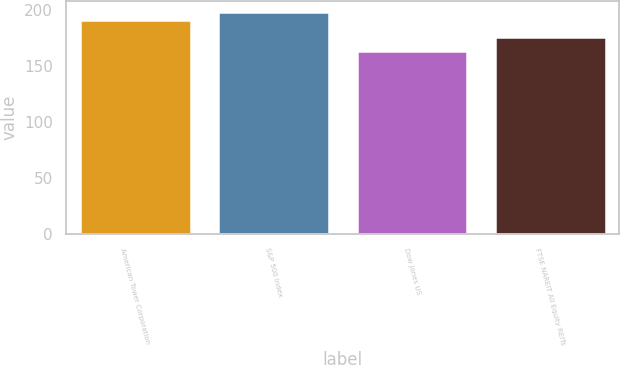Convert chart to OTSL. <chart><loc_0><loc_0><loc_500><loc_500><bar_chart><fcel>American Tower Corporation<fcel>S&P 500 Index<fcel>Dow Jones US<fcel>FTSE NAREIT All Equity REITs<nl><fcel>191.16<fcel>198.18<fcel>163.17<fcel>176.07<nl></chart> 